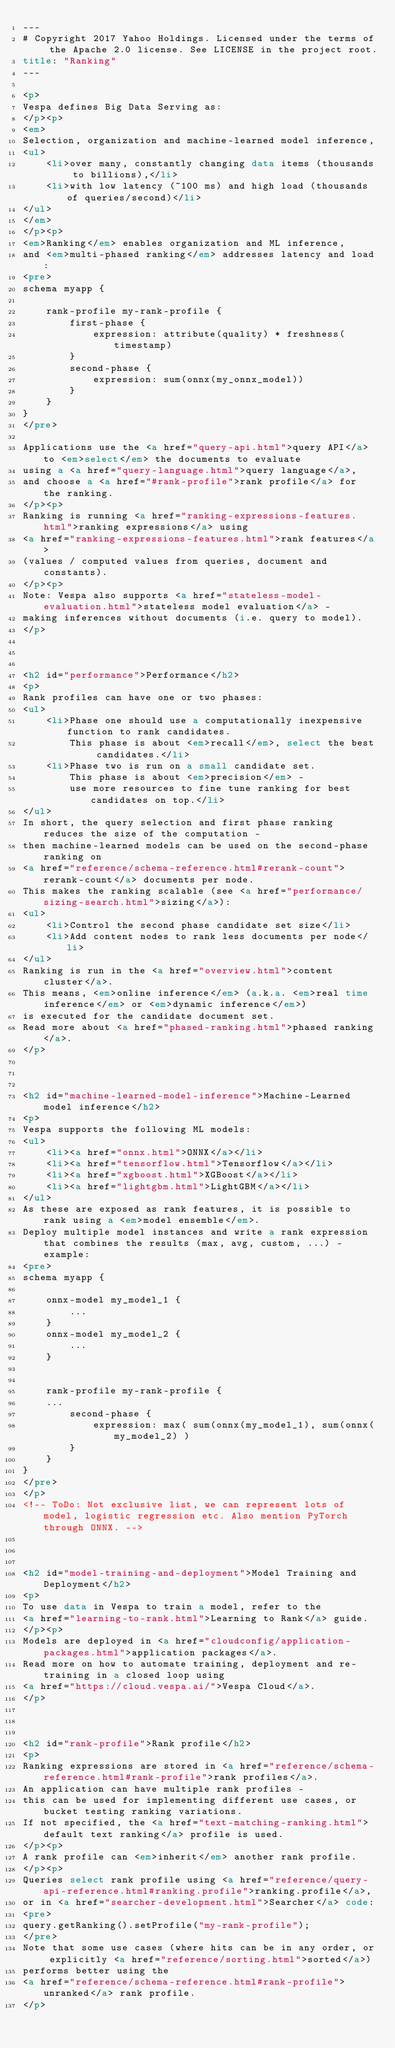<code> <loc_0><loc_0><loc_500><loc_500><_HTML_>---
# Copyright 2017 Yahoo Holdings. Licensed under the terms of the Apache 2.0 license. See LICENSE in the project root.
title: "Ranking"
---

<p>
Vespa defines Big Data Serving as:
</p><p>
<em>
Selection, organization and machine-learned model inference,
<ul>
    <li>over many, constantly changing data items (thousands to billions),</li>
    <li>with low latency (~100 ms) and high load (thousands of queries/second)</li>
</ul>
</em>
</p><p>
<em>Ranking</em> enables organization and ML inference,
and <em>multi-phased ranking</em> addresses latency and load:
<pre>
schema myapp {

    rank-profile my-rank-profile {
        first-phase {
            expression: attribute(quality) * freshness(timestamp)
        }
        second-phase {
            expression: sum(onnx(my_onnx_model))
        }
    }
}
</pre>

Applications use the <a href="query-api.html">query API</a> to <em>select</em> the documents to evaluate
using a <a href="query-language.html">query language</a>,
and choose a <a href="#rank-profile">rank profile</a> for the ranking.
</p><p>
Ranking is running <a href="ranking-expressions-features.html">ranking expressions</a> using
<a href="ranking-expressions-features.html">rank features</a>
(values / computed values from queries, document and constants).
</p><p>
Note: Vespa also supports <a href="stateless-model-evaluation.html">stateless model evaluation</a> -
making inferences without documents (i.e. query to model).
</p>



<h2 id="performance">Performance</h2>
<p>
Rank profiles can have one or two phases:
<ul>
    <li>Phase one should use a computationally inexpensive function to rank candidates.
        This phase is about <em>recall</em>, select the best candidates.</li>
    <li>Phase two is run on a small candidate set.
        This phase is about <em>precision</em> -
        use more resources to fine tune ranking for best candidates on top.</li>
</ul>
In short, the query selection and first phase ranking reduces the size of the computation -
then machine-learned models can be used on the second-phase ranking on
<a href="reference/schema-reference.html#rerank-count">rerank-count</a> documents per node.
This makes the ranking scalable (see <a href="performance/sizing-search.html">sizing</a>):
<ul>
    <li>Control the second phase candidate set size</li>
    <li>Add content nodes to rank less documents per node</li>
</ul>
Ranking is run in the <a href="overview.html">content cluster</a>.
This means, <em>online inference</em> (a.k.a. <em>real time inference</em> or <em>dynamic inference</em>)
is executed for the candidate document set.
Read more about <a href="phased-ranking.html">phased ranking</a>.
</p>



<h2 id="machine-learned-model-inference">Machine-Learned model inference</h2>
<p>
Vespa supports the following ML models:
<ul>
    <li><a href="onnx.html">ONNX</a></li>
    <li><a href="tensorflow.html">Tensorflow</a></li>
    <li><a href="xgboost.html">XGBoost</a></li>
    <li><a href="lightgbm.html">LightGBM</a></li>
</ul>
As these are exposed as rank features, it is possible to rank using a <em>model ensemble</em>.
Deploy multiple model instances and write a rank expression that combines the results (max, avg, custom, ...) - example:
<pre>
schema myapp {

    onnx-model my_model_1 {
        ...
    }
    onnx-model my_model_2 {
        ...
    }


    rank-profile my-rank-profile {
    ...
        second-phase {
            expression: max( sum(onnx(my_model_1), sum(onnx(my_model_2) )
        }
    }
}
</pre>
</p>
<!-- ToDo: Not exclusive list, we can represent lots of model, logistic regression etc. Also mention PyTorch through ONNX. -->



<h2 id="model-training-and-deployment">Model Training and Deployment</h2>
<p>
To use data in Vespa to train a model, refer to the
<a href="learning-to-rank.html">Learning to Rank</a> guide.
</p><p>
Models are deployed in <a href="cloudconfig/application-packages.html">application packages</a>.
Read more on how to automate training, deployment and re-training in a closed loop using
<a href="https://cloud.vespa.ai/">Vespa Cloud</a>.
</p>



<h2 id="rank-profile">Rank profile</h2>
<p>
Ranking expressions are stored in <a href="reference/schema-reference.html#rank-profile">rank profiles</a>.
An application can have multiple rank profiles -
this can be used for implementing different use cases, or bucket testing ranking variations.
If not specified, the <a href="text-matching-ranking.html">default text ranking</a> profile is used.
</p><p>
A rank profile can <em>inherit</em> another rank profile.
</p><p>
Queries select rank profile using <a href="reference/query-api-reference.html#ranking.profile">ranking.profile</a>,
or in <a href="searcher-development.html">Searcher</a> code:
<pre>
query.getRanking().setProfile("my-rank-profile");
</pre>
Note that some use cases (where hits can be in any order, or explicitly <a href="reference/sorting.html">sorted</a>)
performs better using the
<a href="reference/schema-reference.html#rank-profile">unranked</a> rank profile.
</p>
</code> 